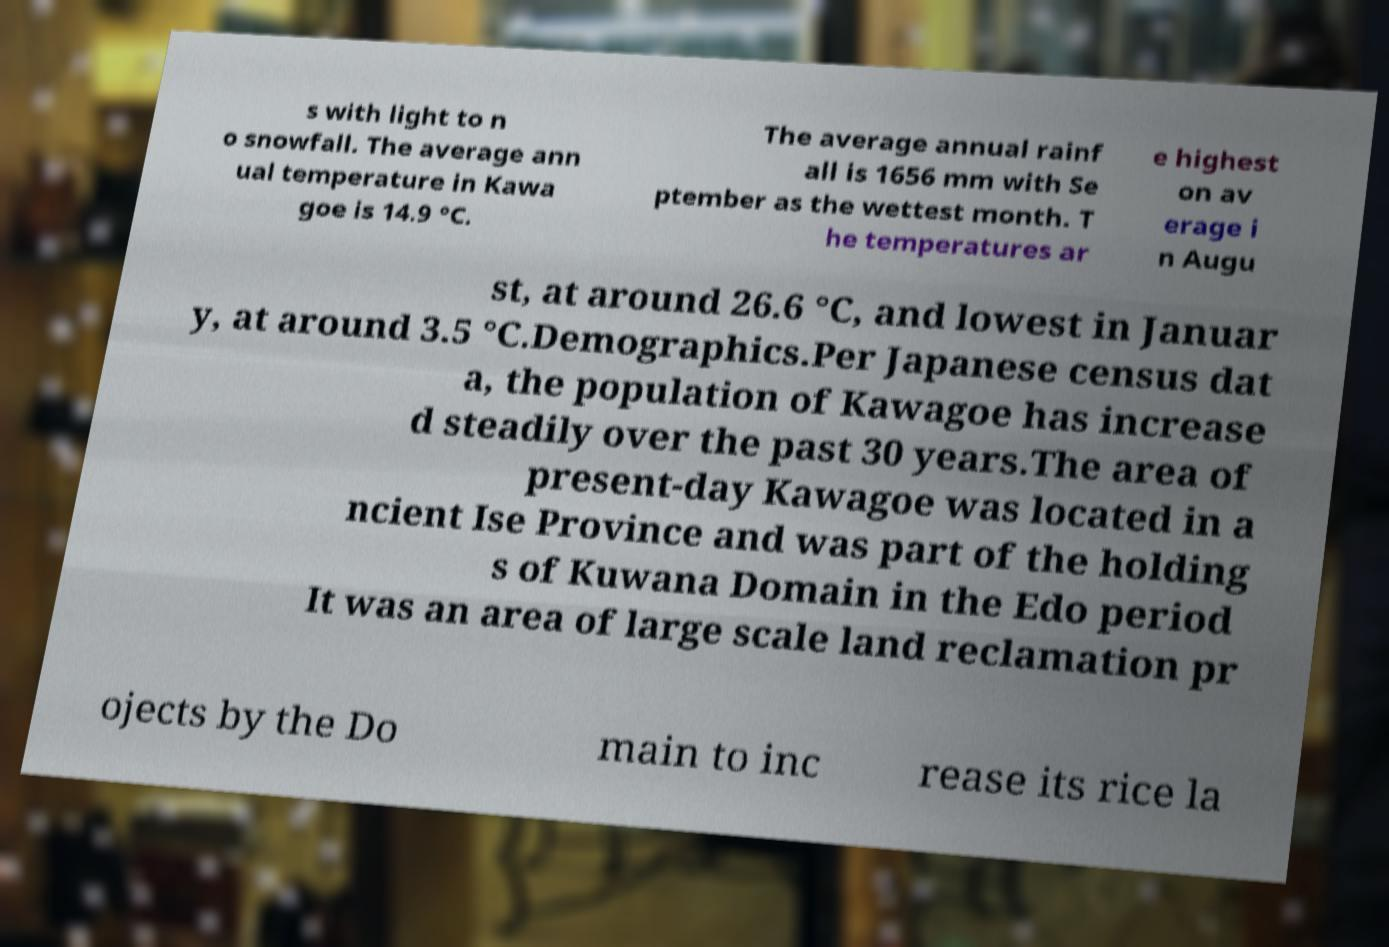For documentation purposes, I need the text within this image transcribed. Could you provide that? s with light to n o snowfall. The average ann ual temperature in Kawa goe is 14.9 °C. The average annual rainf all is 1656 mm with Se ptember as the wettest month. T he temperatures ar e highest on av erage i n Augu st, at around 26.6 °C, and lowest in Januar y, at around 3.5 °C.Demographics.Per Japanese census dat a, the population of Kawagoe has increase d steadily over the past 30 years.The area of present-day Kawagoe was located in a ncient Ise Province and was part of the holding s of Kuwana Domain in the Edo period It was an area of large scale land reclamation pr ojects by the Do main to inc rease its rice la 